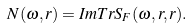Convert formula to latex. <formula><loc_0><loc_0><loc_500><loc_500>N ( \omega , r ) = I m T r S _ { F } ( \omega , r , r ) .</formula> 